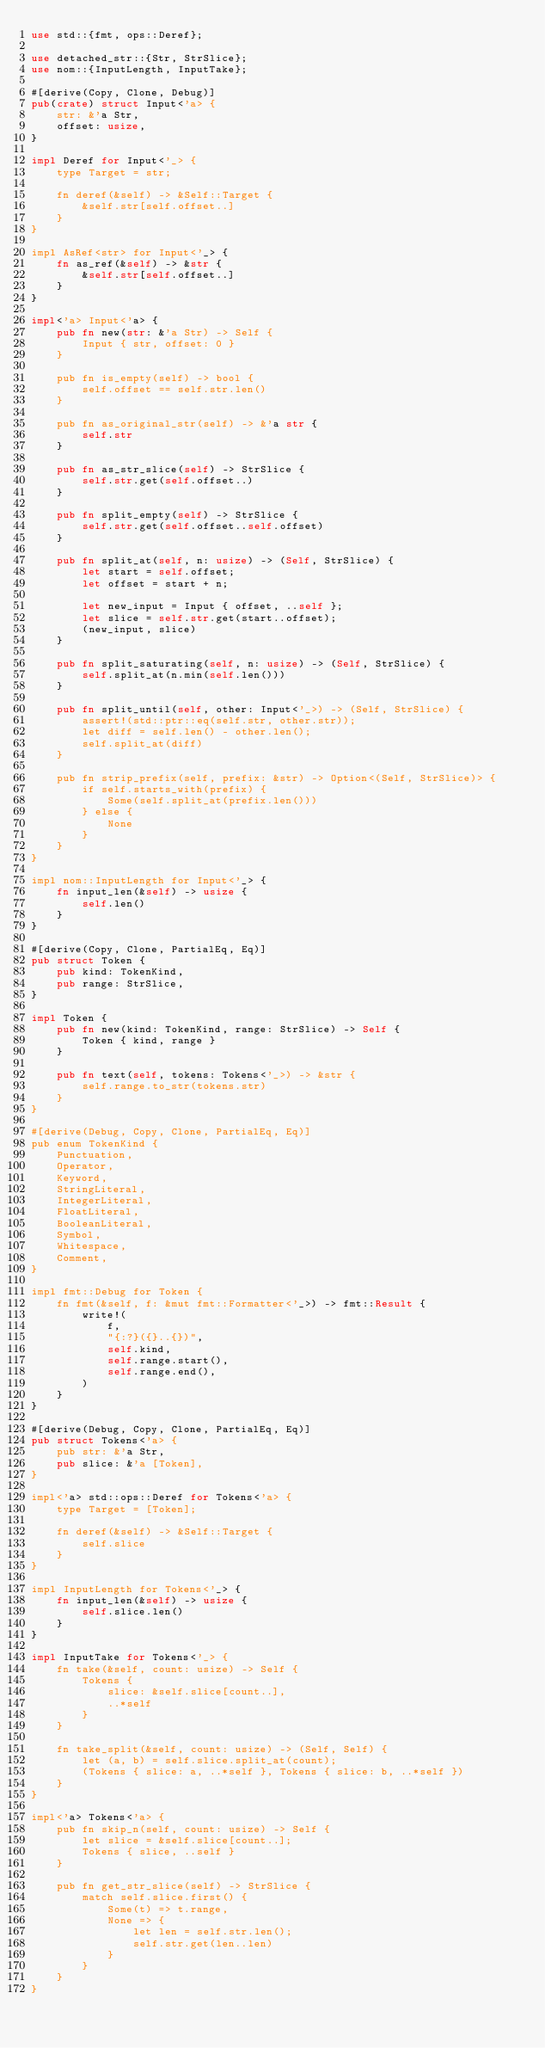<code> <loc_0><loc_0><loc_500><loc_500><_Rust_>use std::{fmt, ops::Deref};

use detached_str::{Str, StrSlice};
use nom::{InputLength, InputTake};

#[derive(Copy, Clone, Debug)]
pub(crate) struct Input<'a> {
    str: &'a Str,
    offset: usize,
}

impl Deref for Input<'_> {
    type Target = str;

    fn deref(&self) -> &Self::Target {
        &self.str[self.offset..]
    }
}

impl AsRef<str> for Input<'_> {
    fn as_ref(&self) -> &str {
        &self.str[self.offset..]
    }
}

impl<'a> Input<'a> {
    pub fn new(str: &'a Str) -> Self {
        Input { str, offset: 0 }
    }

    pub fn is_empty(self) -> bool {
        self.offset == self.str.len()
    }

    pub fn as_original_str(self) -> &'a str {
        self.str
    }

    pub fn as_str_slice(self) -> StrSlice {
        self.str.get(self.offset..)
    }

    pub fn split_empty(self) -> StrSlice {
        self.str.get(self.offset..self.offset)
    }

    pub fn split_at(self, n: usize) -> (Self, StrSlice) {
        let start = self.offset;
        let offset = start + n;

        let new_input = Input { offset, ..self };
        let slice = self.str.get(start..offset);
        (new_input, slice)
    }

    pub fn split_saturating(self, n: usize) -> (Self, StrSlice) {
        self.split_at(n.min(self.len()))
    }

    pub fn split_until(self, other: Input<'_>) -> (Self, StrSlice) {
        assert!(std::ptr::eq(self.str, other.str));
        let diff = self.len() - other.len();
        self.split_at(diff)
    }

    pub fn strip_prefix(self, prefix: &str) -> Option<(Self, StrSlice)> {
        if self.starts_with(prefix) {
            Some(self.split_at(prefix.len()))
        } else {
            None
        }
    }
}

impl nom::InputLength for Input<'_> {
    fn input_len(&self) -> usize {
        self.len()
    }
}

#[derive(Copy, Clone, PartialEq, Eq)]
pub struct Token {
    pub kind: TokenKind,
    pub range: StrSlice,
}

impl Token {
    pub fn new(kind: TokenKind, range: StrSlice) -> Self {
        Token { kind, range }
    }

    pub fn text(self, tokens: Tokens<'_>) -> &str {
        self.range.to_str(tokens.str)
    }
}

#[derive(Debug, Copy, Clone, PartialEq, Eq)]
pub enum TokenKind {
    Punctuation,
    Operator,
    Keyword,
    StringLiteral,
    IntegerLiteral,
    FloatLiteral,
    BooleanLiteral,
    Symbol,
    Whitespace,
    Comment,
}

impl fmt::Debug for Token {
    fn fmt(&self, f: &mut fmt::Formatter<'_>) -> fmt::Result {
        write!(
            f,
            "{:?}({}..{})",
            self.kind,
            self.range.start(),
            self.range.end(),
        )
    }
}

#[derive(Debug, Copy, Clone, PartialEq, Eq)]
pub struct Tokens<'a> {
    pub str: &'a Str,
    pub slice: &'a [Token],
}

impl<'a> std::ops::Deref for Tokens<'a> {
    type Target = [Token];

    fn deref(&self) -> &Self::Target {
        self.slice
    }
}

impl InputLength for Tokens<'_> {
    fn input_len(&self) -> usize {
        self.slice.len()
    }
}

impl InputTake for Tokens<'_> {
    fn take(&self, count: usize) -> Self {
        Tokens {
            slice: &self.slice[count..],
            ..*self
        }
    }

    fn take_split(&self, count: usize) -> (Self, Self) {
        let (a, b) = self.slice.split_at(count);
        (Tokens { slice: a, ..*self }, Tokens { slice: b, ..*self })
    }
}

impl<'a> Tokens<'a> {
    pub fn skip_n(self, count: usize) -> Self {
        let slice = &self.slice[count..];
        Tokens { slice, ..self }
    }

    pub fn get_str_slice(self) -> StrSlice {
        match self.slice.first() {
            Some(t) => t.range,
            None => {
                let len = self.str.len();
                self.str.get(len..len)
            }
        }
    }
}
</code> 